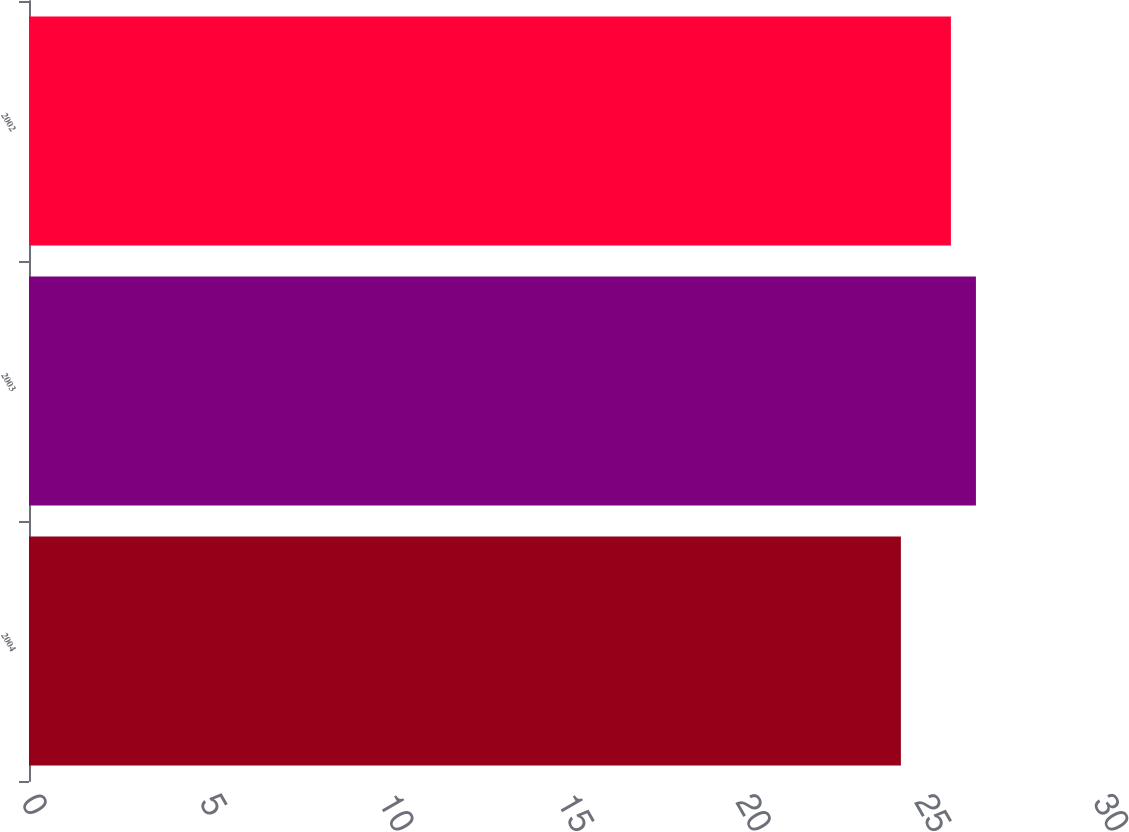<chart> <loc_0><loc_0><loc_500><loc_500><bar_chart><fcel>2004<fcel>2003<fcel>2002<nl><fcel>24.4<fcel>26.5<fcel>25.8<nl></chart> 